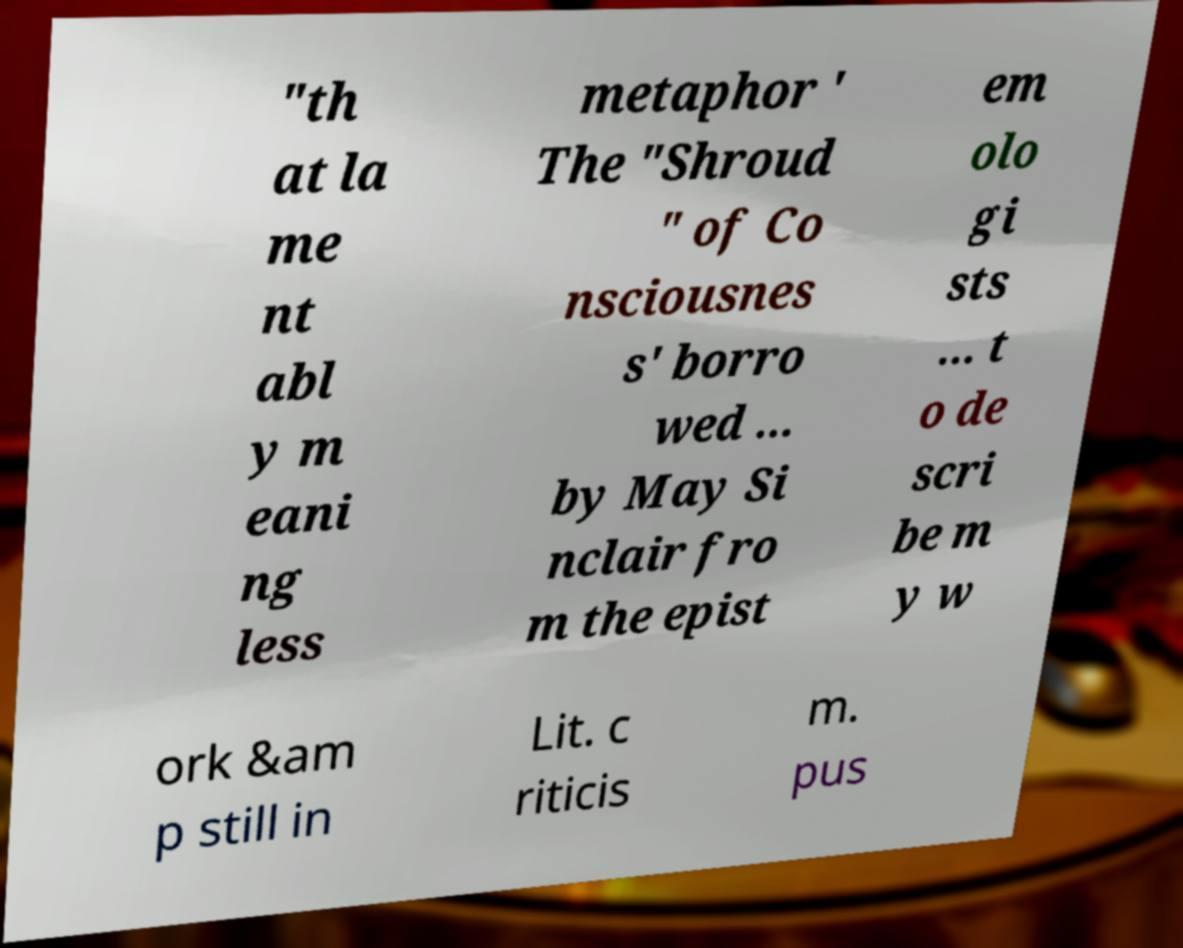Please read and relay the text visible in this image. What does it say? "th at la me nt abl y m eani ng less metaphor ' The "Shroud " of Co nsciousnes s' borro wed ... by May Si nclair fro m the epist em olo gi sts ... t o de scri be m y w ork &am p still in Lit. c riticis m. pus 